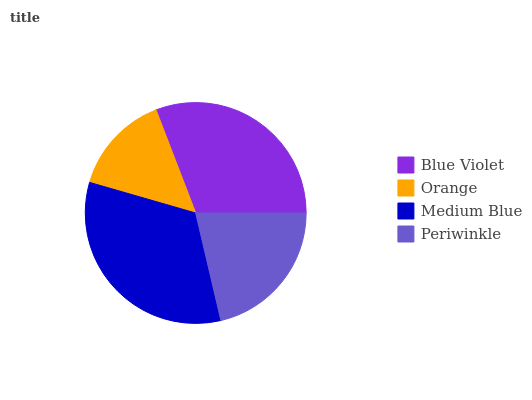Is Orange the minimum?
Answer yes or no. Yes. Is Medium Blue the maximum?
Answer yes or no. Yes. Is Medium Blue the minimum?
Answer yes or no. No. Is Orange the maximum?
Answer yes or no. No. Is Medium Blue greater than Orange?
Answer yes or no. Yes. Is Orange less than Medium Blue?
Answer yes or no. Yes. Is Orange greater than Medium Blue?
Answer yes or no. No. Is Medium Blue less than Orange?
Answer yes or no. No. Is Blue Violet the high median?
Answer yes or no. Yes. Is Periwinkle the low median?
Answer yes or no. Yes. Is Orange the high median?
Answer yes or no. No. Is Blue Violet the low median?
Answer yes or no. No. 